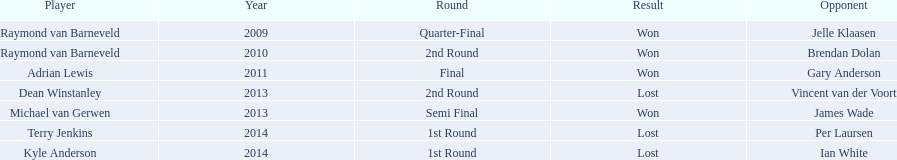Who won the first world darts championship? Raymond van Barneveld. I'm looking to parse the entire table for insights. Could you assist me with that? {'header': ['Player', 'Year', 'Round', 'Result', 'Opponent'], 'rows': [['Raymond van Barneveld', '2009', 'Quarter-Final', 'Won', 'Jelle Klaasen'], ['Raymond van Barneveld', '2010', '2nd Round', 'Won', 'Brendan Dolan'], ['Adrian Lewis', '2011', 'Final', 'Won', 'Gary Anderson'], ['Dean Winstanley', '2013', '2nd Round', 'Lost', 'Vincent van der Voort'], ['Michael van Gerwen', '2013', 'Semi Final', 'Won', 'James Wade'], ['Terry Jenkins', '2014', '1st Round', 'Lost', 'Per Laursen'], ['Kyle Anderson', '2014', '1st Round', 'Lost', 'Ian White']]} 